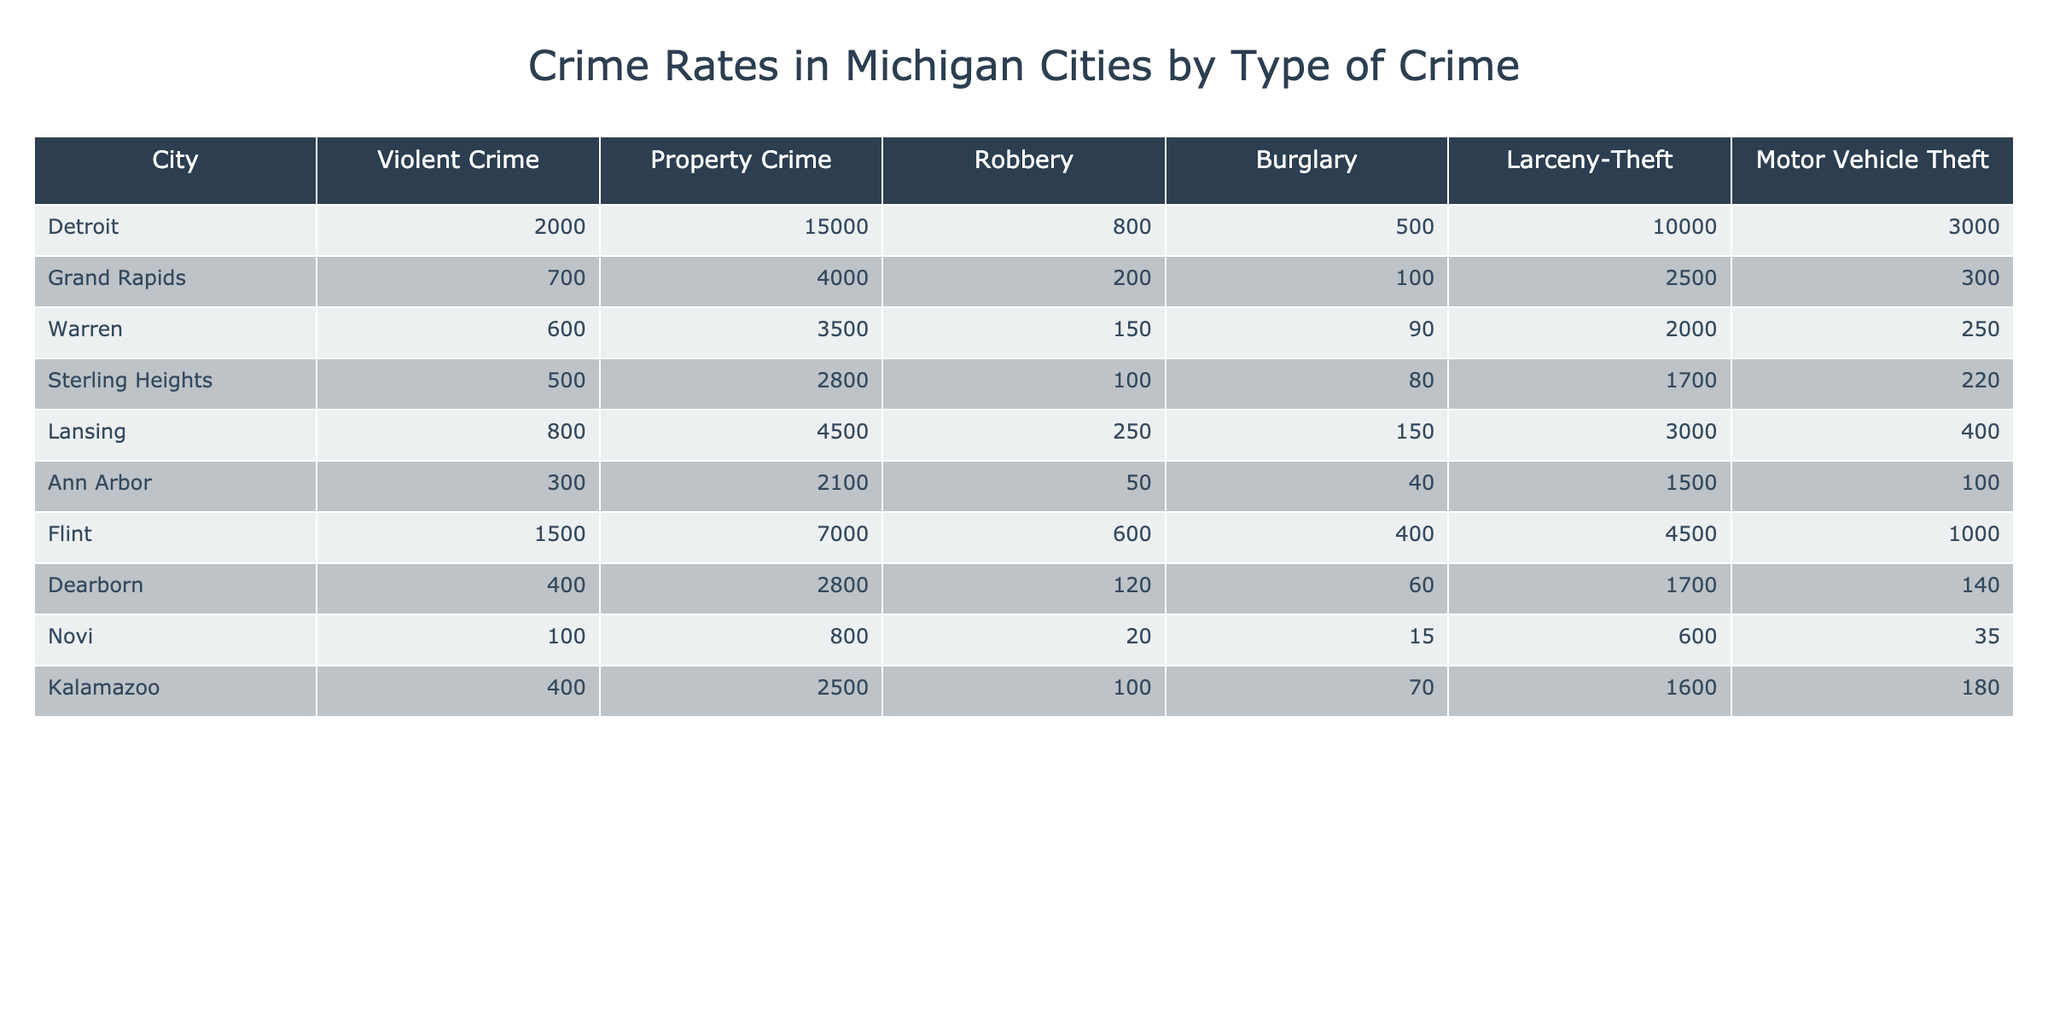What city has the highest violent crime rate? By looking through the 'Violent Crime' column in the table, Detroit has the highest value at 2000.
Answer: Detroit What is the total property crime rate for the cities listed? To find the total property crime rate, sum the values in the 'Property Crime' column: 15000 + 4000 + 3500 + 2800 + 4500 + 2100 + 7000 + 2800 + 800 + 2500 = 33600.
Answer: 33600 Is there a city with zero reports of motor vehicle theft? Scanning through the 'Motor Vehicle Theft' column, every city has values greater than zero, confirming there are no cities with zero reports.
Answer: No Which city has the lowest property crime rate? The 'Property Crime' column shows that Novi has the lowest value of 800.
Answer: Novi What is the average larceny-theft rate across all cities? To calculate the average, sum the values in the 'Larceny-Theft' column: 10000 + 2500 + 2000 + 1700 + 3000 + 1500 + 4500 + 1700 + 600 + 1600 = 44500, and then divide by the number of cities (10): 44500 / 10 = 4450.
Answer: 4450 Which city has a higher robbery rate, Grand Rapids or Warren? Comparing the 'Robbery' values, Grand Rapids has 200 and Warren has 150. Since 200 is greater than 150, Grand Rapids has a higher robbery rate.
Answer: Grand Rapids What type of crime is the most prevalent in Flint? Looking at Flint's row in the table, the 'Property Crime' value is 7000 while the 'Violent Crime' value is 1500, indicating that the most prevalent type of crime in Flint is property crime.
Answer: Property crime What city has the same number of burglaries as Robbery? Scanning the 'Burglary' and 'Robbery' columns: Sterling Heights has 80 burglaries and 100 robberies. No city matches these counts. Therefore, no city has the same number.
Answer: No city 